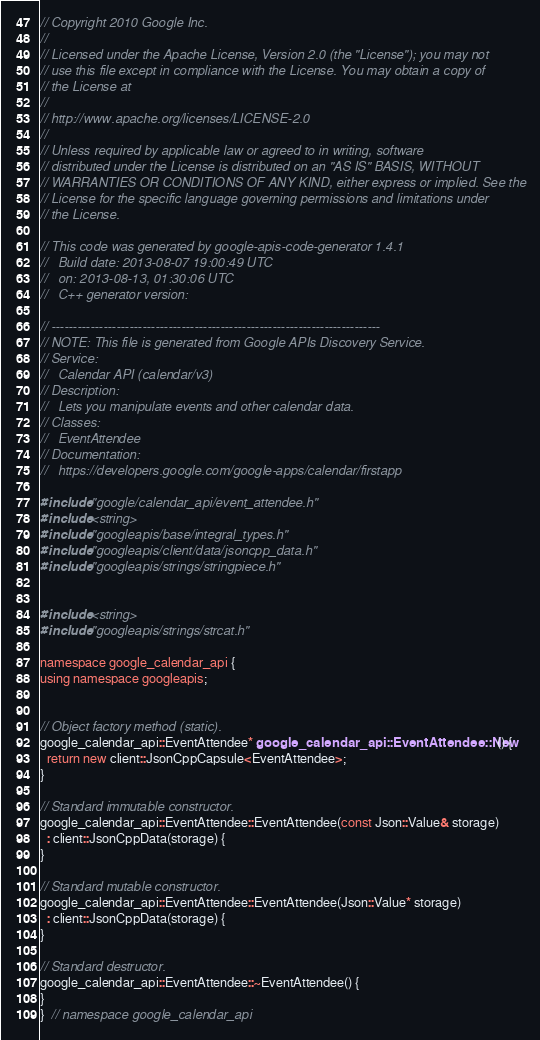Convert code to text. <code><loc_0><loc_0><loc_500><loc_500><_C++_>// Copyright 2010 Google Inc.
//
// Licensed under the Apache License, Version 2.0 (the "License"); you may not
// use this file except in compliance with the License. You may obtain a copy of
// the License at
//
// http://www.apache.org/licenses/LICENSE-2.0
//
// Unless required by applicable law or agreed to in writing, software
// distributed under the License is distributed on an "AS IS" BASIS, WITHOUT
// WARRANTIES OR CONDITIONS OF ANY KIND, either express or implied. See the
// License for the specific language governing permissions and limitations under
// the License.

// This code was generated by google-apis-code-generator 1.4.1
//   Build date: 2013-08-07 19:00:49 UTC
//   on: 2013-08-13, 01:30:06 UTC
//   C++ generator version:

// ----------------------------------------------------------------------------
// NOTE: This file is generated from Google APIs Discovery Service.
// Service:
//   Calendar API (calendar/v3)
// Description:
//   Lets you manipulate events and other calendar data.
// Classes:
//   EventAttendee
// Documentation:
//   https://developers.google.com/google-apps/calendar/firstapp

#include "google/calendar_api/event_attendee.h"
#include <string>
#include "googleapis/base/integral_types.h"
#include "googleapis/client/data/jsoncpp_data.h"
#include "googleapis/strings/stringpiece.h"


#include <string>
#include "googleapis/strings/strcat.h"

namespace google_calendar_api {
using namespace googleapis;


// Object factory method (static).
google_calendar_api::EventAttendee* google_calendar_api::EventAttendee::New() {
  return new client::JsonCppCapsule<EventAttendee>;
}

// Standard immutable constructor.
google_calendar_api::EventAttendee::EventAttendee(const Json::Value& storage)
  : client::JsonCppData(storage) {
}

// Standard mutable constructor.
google_calendar_api::EventAttendee::EventAttendee(Json::Value* storage)
  : client::JsonCppData(storage) {
}

// Standard destructor.
google_calendar_api::EventAttendee::~EventAttendee() {
}
}  // namespace google_calendar_api
</code> 